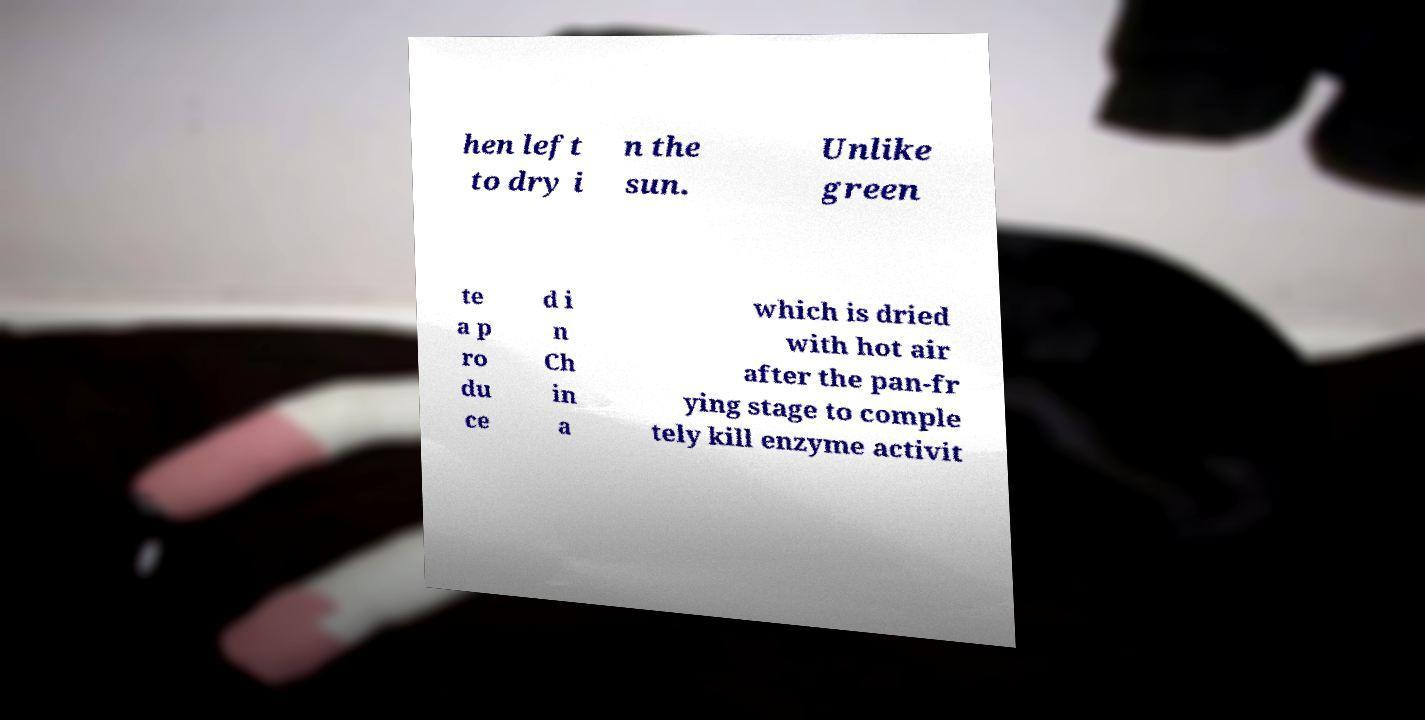Can you accurately transcribe the text from the provided image for me? hen left to dry i n the sun. Unlike green te a p ro du ce d i n Ch in a which is dried with hot air after the pan-fr ying stage to comple tely kill enzyme activit 